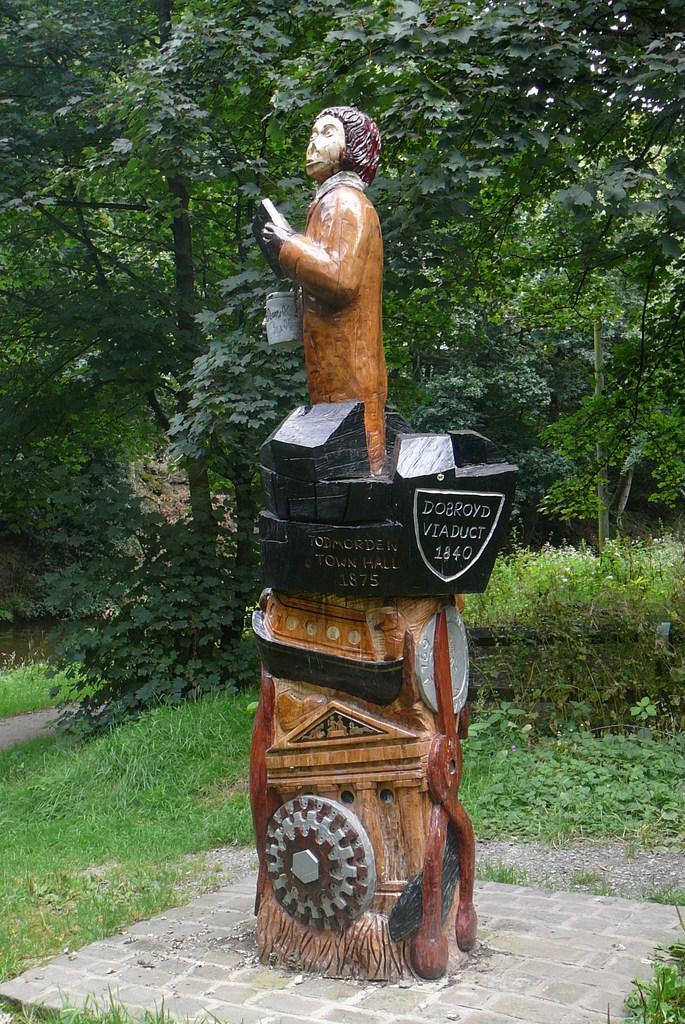In one or two sentences, can you explain what this image depicts? In the center of the image there is a statue with some text. In the background of the image there are trees, grass, plants. 